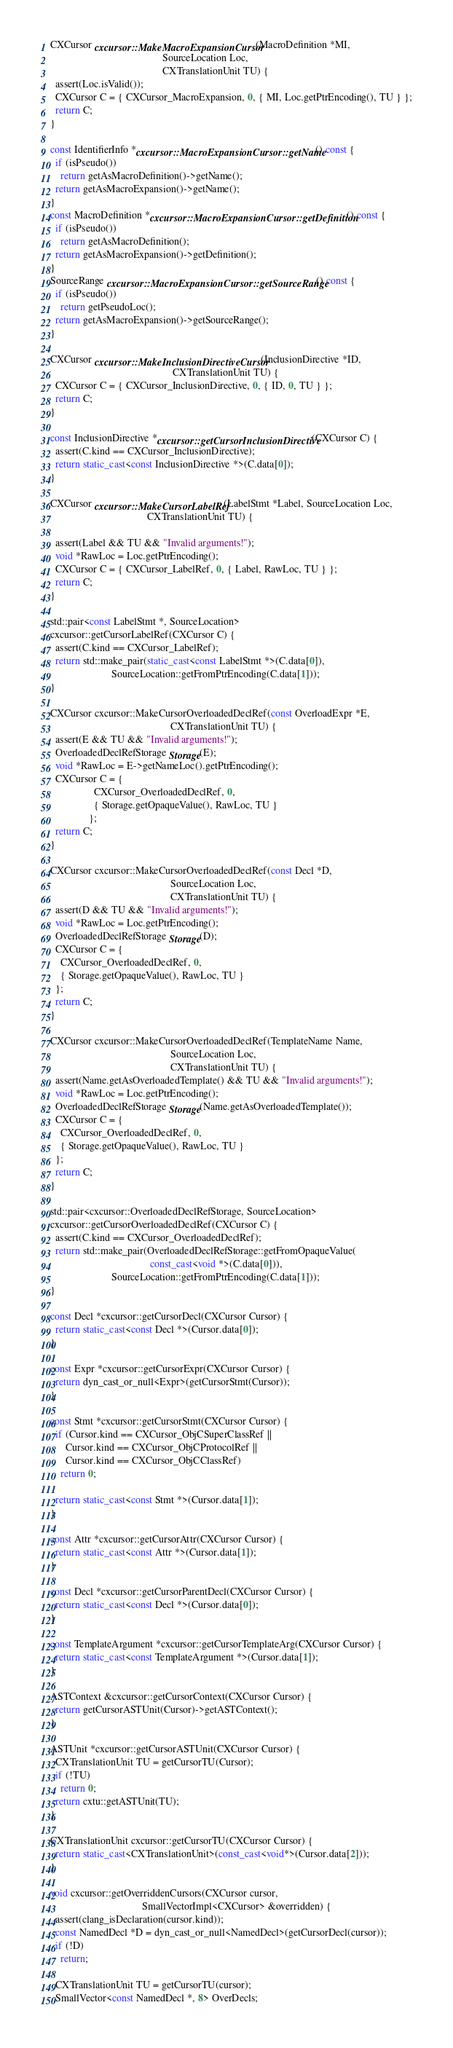<code> <loc_0><loc_0><loc_500><loc_500><_C++_>CXCursor cxcursor::MakeMacroExpansionCursor(MacroDefinition *MI,
                                            SourceLocation Loc,
                                            CXTranslationUnit TU) {
  assert(Loc.isValid());
  CXCursor C = { CXCursor_MacroExpansion, 0, { MI, Loc.getPtrEncoding(), TU } };
  return C;
}

const IdentifierInfo *cxcursor::MacroExpansionCursor::getName() const {
  if (isPseudo())
    return getAsMacroDefinition()->getName();
  return getAsMacroExpansion()->getName();
}
const MacroDefinition *cxcursor::MacroExpansionCursor::getDefinition() const {
  if (isPseudo())
    return getAsMacroDefinition();
  return getAsMacroExpansion()->getDefinition();
}
SourceRange cxcursor::MacroExpansionCursor::getSourceRange() const {
  if (isPseudo())
    return getPseudoLoc();
  return getAsMacroExpansion()->getSourceRange();
}

CXCursor cxcursor::MakeInclusionDirectiveCursor(InclusionDirective *ID, 
                                                CXTranslationUnit TU) {
  CXCursor C = { CXCursor_InclusionDirective, 0, { ID, 0, TU } };
  return C;
}

const InclusionDirective *cxcursor::getCursorInclusionDirective(CXCursor C) {
  assert(C.kind == CXCursor_InclusionDirective);
  return static_cast<const InclusionDirective *>(C.data[0]);
}

CXCursor cxcursor::MakeCursorLabelRef(LabelStmt *Label, SourceLocation Loc, 
                                      CXTranslationUnit TU) {
  
  assert(Label && TU && "Invalid arguments!");
  void *RawLoc = Loc.getPtrEncoding();
  CXCursor C = { CXCursor_LabelRef, 0, { Label, RawLoc, TU } };
  return C;    
}

std::pair<const LabelStmt *, SourceLocation>
cxcursor::getCursorLabelRef(CXCursor C) {
  assert(C.kind == CXCursor_LabelRef);
  return std::make_pair(static_cast<const LabelStmt *>(C.data[0]),
                        SourceLocation::getFromPtrEncoding(C.data[1]));
}

CXCursor cxcursor::MakeCursorOverloadedDeclRef(const OverloadExpr *E,
                                               CXTranslationUnit TU) {
  assert(E && TU && "Invalid arguments!");
  OverloadedDeclRefStorage Storage(E);
  void *RawLoc = E->getNameLoc().getPtrEncoding();
  CXCursor C = { 
                 CXCursor_OverloadedDeclRef, 0,
                 { Storage.getOpaqueValue(), RawLoc, TU } 
               };
  return C;    
}

CXCursor cxcursor::MakeCursorOverloadedDeclRef(const Decl *D,
                                               SourceLocation Loc,
                                               CXTranslationUnit TU) {
  assert(D && TU && "Invalid arguments!");
  void *RawLoc = Loc.getPtrEncoding();
  OverloadedDeclRefStorage Storage(D);
  CXCursor C = { 
    CXCursor_OverloadedDeclRef, 0,
    { Storage.getOpaqueValue(), RawLoc, TU }
  };
  return C;    
}

CXCursor cxcursor::MakeCursorOverloadedDeclRef(TemplateName Name, 
                                               SourceLocation Loc,
                                               CXTranslationUnit TU) {
  assert(Name.getAsOverloadedTemplate() && TU && "Invalid arguments!");
  void *RawLoc = Loc.getPtrEncoding();
  OverloadedDeclRefStorage Storage(Name.getAsOverloadedTemplate());
  CXCursor C = { 
    CXCursor_OverloadedDeclRef, 0,
    { Storage.getOpaqueValue(), RawLoc, TU } 
  };
  return C;    
}

std::pair<cxcursor::OverloadedDeclRefStorage, SourceLocation>
cxcursor::getCursorOverloadedDeclRef(CXCursor C) {
  assert(C.kind == CXCursor_OverloadedDeclRef);
  return std::make_pair(OverloadedDeclRefStorage::getFromOpaqueValue(
                                       const_cast<void *>(C.data[0])),
                        SourceLocation::getFromPtrEncoding(C.data[1]));
}

const Decl *cxcursor::getCursorDecl(CXCursor Cursor) {
  return static_cast<const Decl *>(Cursor.data[0]);
}

const Expr *cxcursor::getCursorExpr(CXCursor Cursor) {
  return dyn_cast_or_null<Expr>(getCursorStmt(Cursor));
}

const Stmt *cxcursor::getCursorStmt(CXCursor Cursor) {
  if (Cursor.kind == CXCursor_ObjCSuperClassRef ||
      Cursor.kind == CXCursor_ObjCProtocolRef ||
      Cursor.kind == CXCursor_ObjCClassRef)
    return 0;

  return static_cast<const Stmt *>(Cursor.data[1]);
}

const Attr *cxcursor::getCursorAttr(CXCursor Cursor) {
  return static_cast<const Attr *>(Cursor.data[1]);
}

const Decl *cxcursor::getCursorParentDecl(CXCursor Cursor) {
  return static_cast<const Decl *>(Cursor.data[0]);
}

const TemplateArgument *cxcursor::getCursorTemplateArg(CXCursor Cursor) {
  return static_cast<const TemplateArgument *>(Cursor.data[1]);
}

ASTContext &cxcursor::getCursorContext(CXCursor Cursor) {
  return getCursorASTUnit(Cursor)->getASTContext();
}

ASTUnit *cxcursor::getCursorASTUnit(CXCursor Cursor) {
  CXTranslationUnit TU = getCursorTU(Cursor);
  if (!TU)
    return 0;
  return cxtu::getASTUnit(TU);
}

CXTranslationUnit cxcursor::getCursorTU(CXCursor Cursor) {
  return static_cast<CXTranslationUnit>(const_cast<void*>(Cursor.data[2]));
}

void cxcursor::getOverriddenCursors(CXCursor cursor,
                                    SmallVectorImpl<CXCursor> &overridden) { 
  assert(clang_isDeclaration(cursor.kind));
  const NamedDecl *D = dyn_cast_or_null<NamedDecl>(getCursorDecl(cursor));
  if (!D)
    return;

  CXTranslationUnit TU = getCursorTU(cursor);
  SmallVector<const NamedDecl *, 8> OverDecls;</code> 